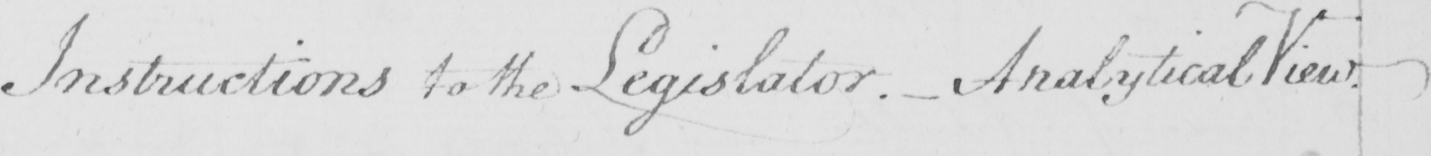Can you tell me what this handwritten text says? Instructions to the Legislator .  _  Analytical View . 